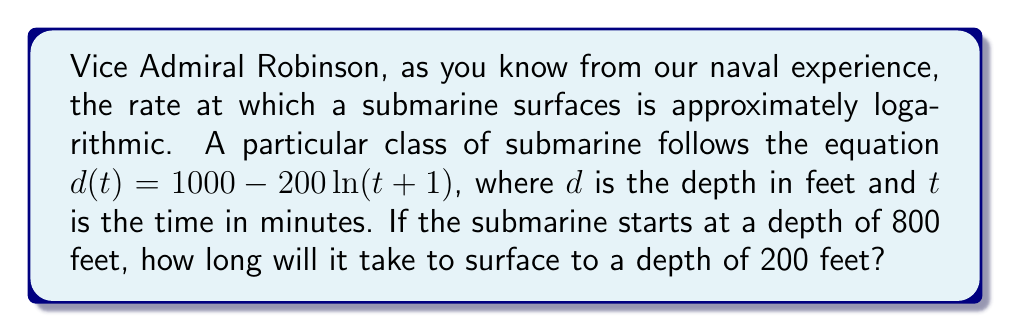Can you answer this question? Let's approach this step-by-step:

1) We start with the equation: $d(t) = 1000 - 200\ln(t+1)$

2) We want to find $t$ when $d(t) = 200$. So, let's substitute this:

   $200 = 1000 - 200\ln(t+1)$

3) Subtract 1000 from both sides:

   $-800 = -200\ln(t+1)$

4) Divide both sides by -200:

   $4 = \ln(t+1)$

5) Now, we can apply the exponential function to both sides to isolate $t+1$:

   $e^4 = e^{\ln(t+1)}$

6) The left side simplifies to $e^4$, and $e^{\ln(x)} = x$, so:

   $e^4 = t+1$

7) Subtract 1 from both sides:

   $e^4 - 1 = t$

8) Calculate the value:

   $t \approx 53.598$ minutes

Therefore, it will take approximately 53.6 minutes for the submarine to surface from 800 feet to 200 feet.
Answer: $t \approx 53.6$ minutes 